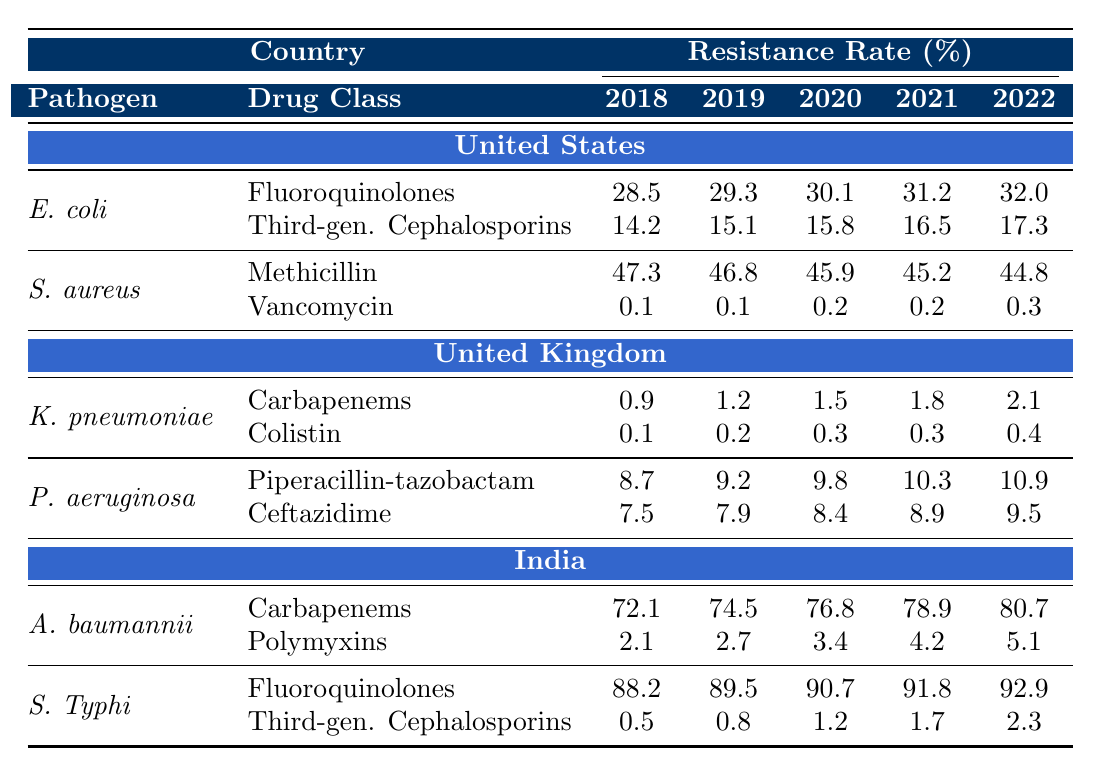What is the resistance rate of Escherichia coli to Fluoroquinolones in 2022 in the United States? The table indicates that the resistance rate of Escherichia coli to Fluoroquinolones in the United States for the year 2022 is listed as 32.0%.
Answer: 32.0% What was the resistance rate of Staphylococcus aureus to Methicillin in 2018? According to the table, the resistance rate of Staphylococcus aureus to Methicillin in 2018 is given as 47.3%.
Answer: 47.3% Which country showed the highest resistance rate of Acinetobacter baumannii to Carbapenems in 2022? The table provides the resistance rate for Acinetobacter baumannii to Carbapenems in India as 80.7%, which is higher than any other country listed.
Answer: India What is the average resistance rate of Klebsiella pneumoniae to Carbapenems from 2018 to 2022 in the United Kingdom? The resistance rates for Klebsiella pneumoniae to Carbapenems from 2018 to 2022 are 0.9%, 1.2%, 1.5%, 1.8%, and 2.1%. Summing these gives 7.5%, and dividing by 5 (the number of years) results in an average of 1.5%.
Answer: 1.5% Did the resistance rate of Salmonella Typhi to Third-generation Cephalosporins increase or decrease from 2018 to 2022 in India? The resistance rates for Salmonella Typhi to Third-generation Cephalosporins from 2018 to 2022 are 0.5%, 0.8%, 1.2%, 1.7%, and 2.3%. Since these rates consistently rise each year, it confirms an increase in resistance over those years.
Answer: Increase Which drug class showed the highest resistance rate for Pseudomonas aeruginosa in the United Kingdom in 2022? The table lists the resistance rates for Pseudomonas aeruginosa to Piperacillin-tazobactam as 10.9% and to Ceftazidime as 9.5% in 2022. The highest rate is thus 10.9% for Piperacillin-tazobactam.
Answer: Piperacillin-tazobactam What was the change in resistance rate of Staphylococcus aureus to Vancomycin from 2018 to 2022 in the United States? The resistance rates for Staphylococcus aureus to Vancomycin from 2018 to 2022 are 0.1%, 0.1%, 0.2%, 0.2%, and 0.3%. The increase from 0.1% in 2018 to 0.3% in 2022 indicates a change of 0.2%.
Answer: 0.2% increase Which pathogen in India had a higher resistance rate to Polymyxins in 2022, Acinetobacter baumannii or Salmonella Typhi? The resistance rate for Acinetobacter baumannii to Polymyxins in 2022 is 5.1%, while for Salmonella Typhi, there is no listed resistance to Polymyxins in 2022. Therefore, Acinetobacter baumannii has a higher resistance rate.
Answer: Acinetobacter baumannii 